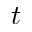Convert formula to latex. <formula><loc_0><loc_0><loc_500><loc_500>t</formula> 